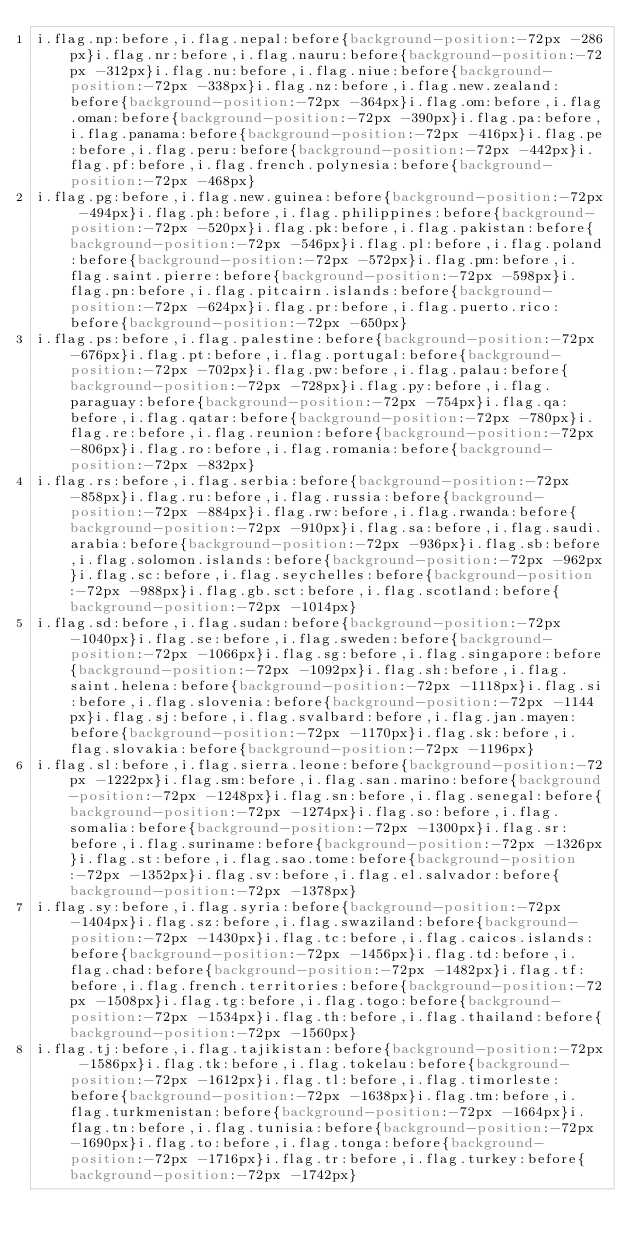Convert code to text. <code><loc_0><loc_0><loc_500><loc_500><_CSS_>i.flag.np:before,i.flag.nepal:before{background-position:-72px -286px}i.flag.nr:before,i.flag.nauru:before{background-position:-72px -312px}i.flag.nu:before,i.flag.niue:before{background-position:-72px -338px}i.flag.nz:before,i.flag.new.zealand:before{background-position:-72px -364px}i.flag.om:before,i.flag.oman:before{background-position:-72px -390px}i.flag.pa:before,i.flag.panama:before{background-position:-72px -416px}i.flag.pe:before,i.flag.peru:before{background-position:-72px -442px}i.flag.pf:before,i.flag.french.polynesia:before{background-position:-72px -468px}
i.flag.pg:before,i.flag.new.guinea:before{background-position:-72px -494px}i.flag.ph:before,i.flag.philippines:before{background-position:-72px -520px}i.flag.pk:before,i.flag.pakistan:before{background-position:-72px -546px}i.flag.pl:before,i.flag.poland:before{background-position:-72px -572px}i.flag.pm:before,i.flag.saint.pierre:before{background-position:-72px -598px}i.flag.pn:before,i.flag.pitcairn.islands:before{background-position:-72px -624px}i.flag.pr:before,i.flag.puerto.rico:before{background-position:-72px -650px}
i.flag.ps:before,i.flag.palestine:before{background-position:-72px -676px}i.flag.pt:before,i.flag.portugal:before{background-position:-72px -702px}i.flag.pw:before,i.flag.palau:before{background-position:-72px -728px}i.flag.py:before,i.flag.paraguay:before{background-position:-72px -754px}i.flag.qa:before,i.flag.qatar:before{background-position:-72px -780px}i.flag.re:before,i.flag.reunion:before{background-position:-72px -806px}i.flag.ro:before,i.flag.romania:before{background-position:-72px -832px}
i.flag.rs:before,i.flag.serbia:before{background-position:-72px -858px}i.flag.ru:before,i.flag.russia:before{background-position:-72px -884px}i.flag.rw:before,i.flag.rwanda:before{background-position:-72px -910px}i.flag.sa:before,i.flag.saudi.arabia:before{background-position:-72px -936px}i.flag.sb:before,i.flag.solomon.islands:before{background-position:-72px -962px}i.flag.sc:before,i.flag.seychelles:before{background-position:-72px -988px}i.flag.gb.sct:before,i.flag.scotland:before{background-position:-72px -1014px}
i.flag.sd:before,i.flag.sudan:before{background-position:-72px -1040px}i.flag.se:before,i.flag.sweden:before{background-position:-72px -1066px}i.flag.sg:before,i.flag.singapore:before{background-position:-72px -1092px}i.flag.sh:before,i.flag.saint.helena:before{background-position:-72px -1118px}i.flag.si:before,i.flag.slovenia:before{background-position:-72px -1144px}i.flag.sj:before,i.flag.svalbard:before,i.flag.jan.mayen:before{background-position:-72px -1170px}i.flag.sk:before,i.flag.slovakia:before{background-position:-72px -1196px}
i.flag.sl:before,i.flag.sierra.leone:before{background-position:-72px -1222px}i.flag.sm:before,i.flag.san.marino:before{background-position:-72px -1248px}i.flag.sn:before,i.flag.senegal:before{background-position:-72px -1274px}i.flag.so:before,i.flag.somalia:before{background-position:-72px -1300px}i.flag.sr:before,i.flag.suriname:before{background-position:-72px -1326px}i.flag.st:before,i.flag.sao.tome:before{background-position:-72px -1352px}i.flag.sv:before,i.flag.el.salvador:before{background-position:-72px -1378px}
i.flag.sy:before,i.flag.syria:before{background-position:-72px -1404px}i.flag.sz:before,i.flag.swaziland:before{background-position:-72px -1430px}i.flag.tc:before,i.flag.caicos.islands:before{background-position:-72px -1456px}i.flag.td:before,i.flag.chad:before{background-position:-72px -1482px}i.flag.tf:before,i.flag.french.territories:before{background-position:-72px -1508px}i.flag.tg:before,i.flag.togo:before{background-position:-72px -1534px}i.flag.th:before,i.flag.thailand:before{background-position:-72px -1560px}
i.flag.tj:before,i.flag.tajikistan:before{background-position:-72px -1586px}i.flag.tk:before,i.flag.tokelau:before{background-position:-72px -1612px}i.flag.tl:before,i.flag.timorleste:before{background-position:-72px -1638px}i.flag.tm:before,i.flag.turkmenistan:before{background-position:-72px -1664px}i.flag.tn:before,i.flag.tunisia:before{background-position:-72px -1690px}i.flag.to:before,i.flag.tonga:before{background-position:-72px -1716px}i.flag.tr:before,i.flag.turkey:before{background-position:-72px -1742px}</code> 